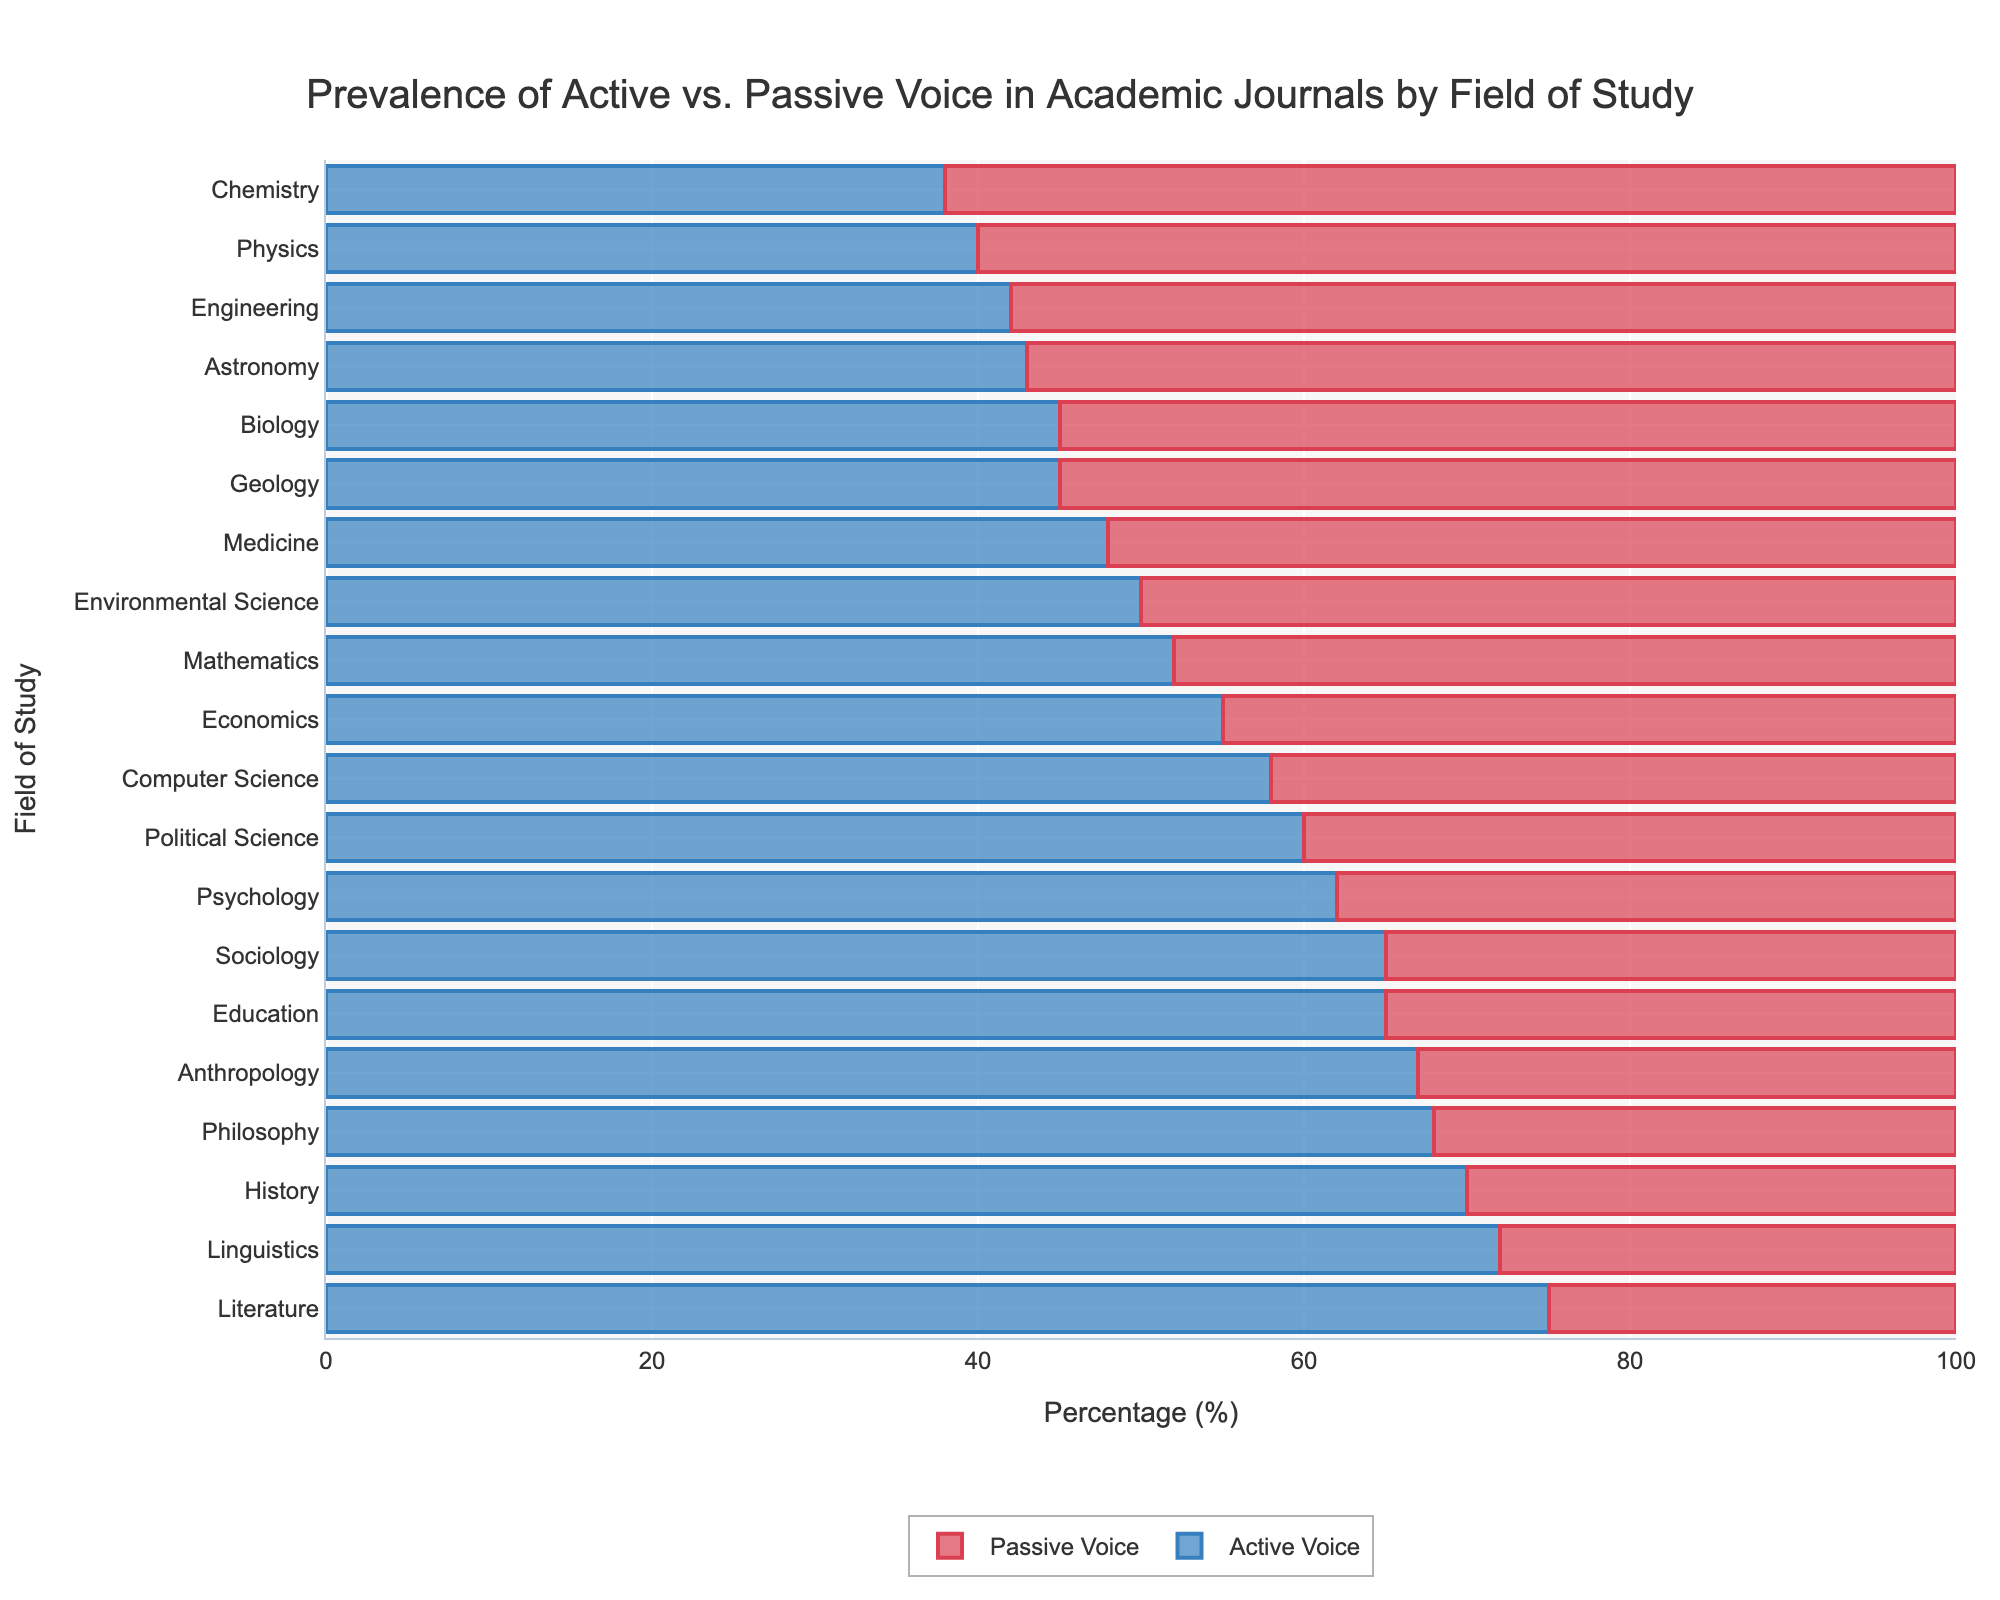What's the most prevalent voice in academic journals in the Philosophy field? In the Philosophy field, the active voice accounts for 68% and the passive voice 32%. Since 68% is higher, the active voice is more prevalent.
Answer: Active voice Which field has the highest prevalence of active voice? The plot shows Literature with the highest percentage of active voice at 75%.
Answer: Literature Compare the usage of active voice in Biology and Sociology. Which field uses it more? In Biology, active voice usage is 45%, while in Sociology it is 65%. Sociology uses the active voice more.
Answer: Sociology Which field uses the passive voice more: Chemistry or Engineering? The passive voice in Chemistry is 62%, and in Engineering, it is 58%. Chemistry uses the passive voice more.
Answer: Chemistry What is the combined prevalence of active voice in Psychology and Political Science fields? Psychology has 62% active voice and Political Science has 60%. Combined, it is 62% + 60% = 122%.
Answer: 122% Is the active voice usage in Environmental Science higher, lower, or the same as in Medicine? Both Environmental Science and Medicine employ the active voice at a rate of 50% and 48%, respectively. Therefore, it is slightly lower in Medicine.
Answer: Lower What is the percentage difference in active voice usage between Literature and Physics? Literature has 75% active voice usage, and Physics has 40%. The difference is 75% – 40% = 35%.
Answer: 35% Which fields have a 50% or higher usage of passive voice? By examining the chart, fields like Biology (55%), Physics (60%), Chemistry (62%), Engineering (58%), and Astronomy (57%) have 50% or higher passive voice usage.
Answer: Biology, Physics, Chemistry, Engineering, Astronomy Compare the total passive voice usage of all science-related fields (Biology, Physics, Chemistry, etc.) with non-science fields (Literature, History, etc.). Sum the passive percentages for science-related fields (55 + 60 + 62 + 48 + 42 + 52 + 50 + 55 + 57) yielding 481% and non-science fields (35 + 30 + 25 + 32 + 45 + 35) giving 202%. Thus, science fields use more passive voice overall.
Answer: Science fields 